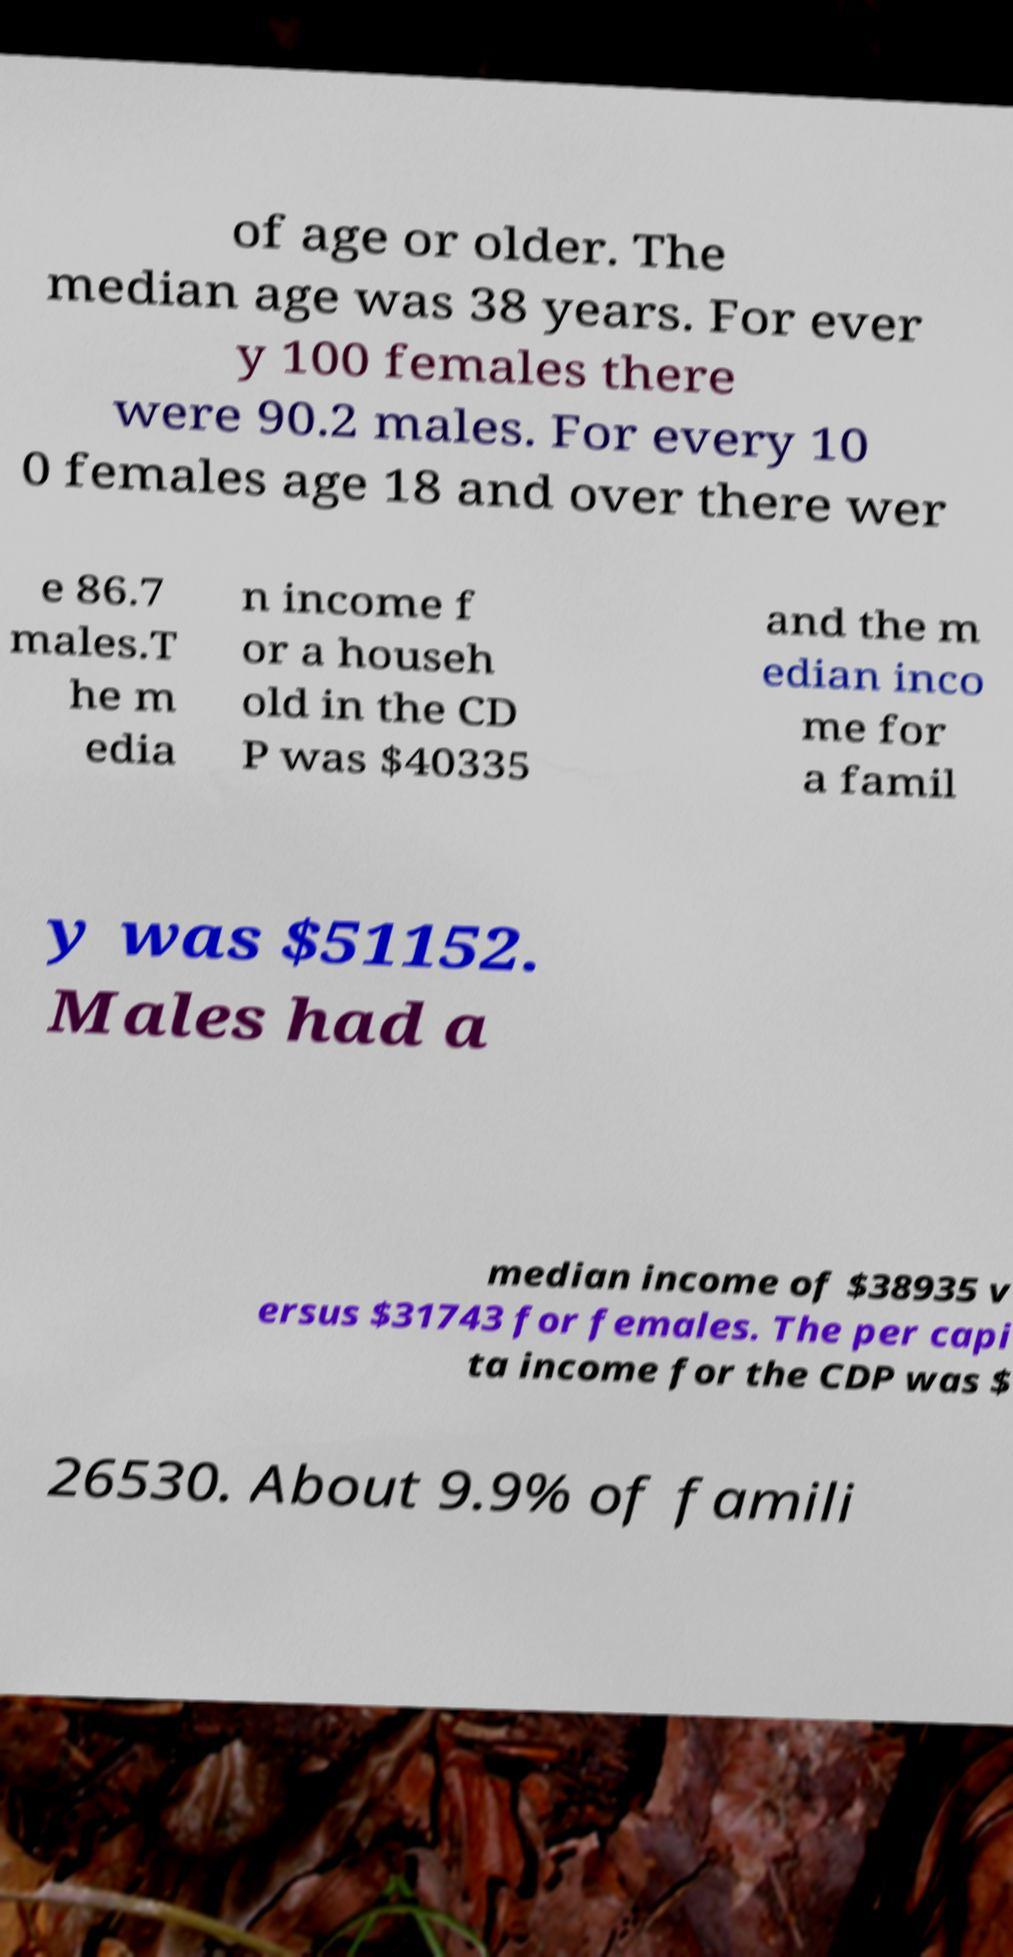Can you accurately transcribe the text from the provided image for me? of age or older. The median age was 38 years. For ever y 100 females there were 90.2 males. For every 10 0 females age 18 and over there wer e 86.7 males.T he m edia n income f or a househ old in the CD P was $40335 and the m edian inco me for a famil y was $51152. Males had a median income of $38935 v ersus $31743 for females. The per capi ta income for the CDP was $ 26530. About 9.9% of famili 